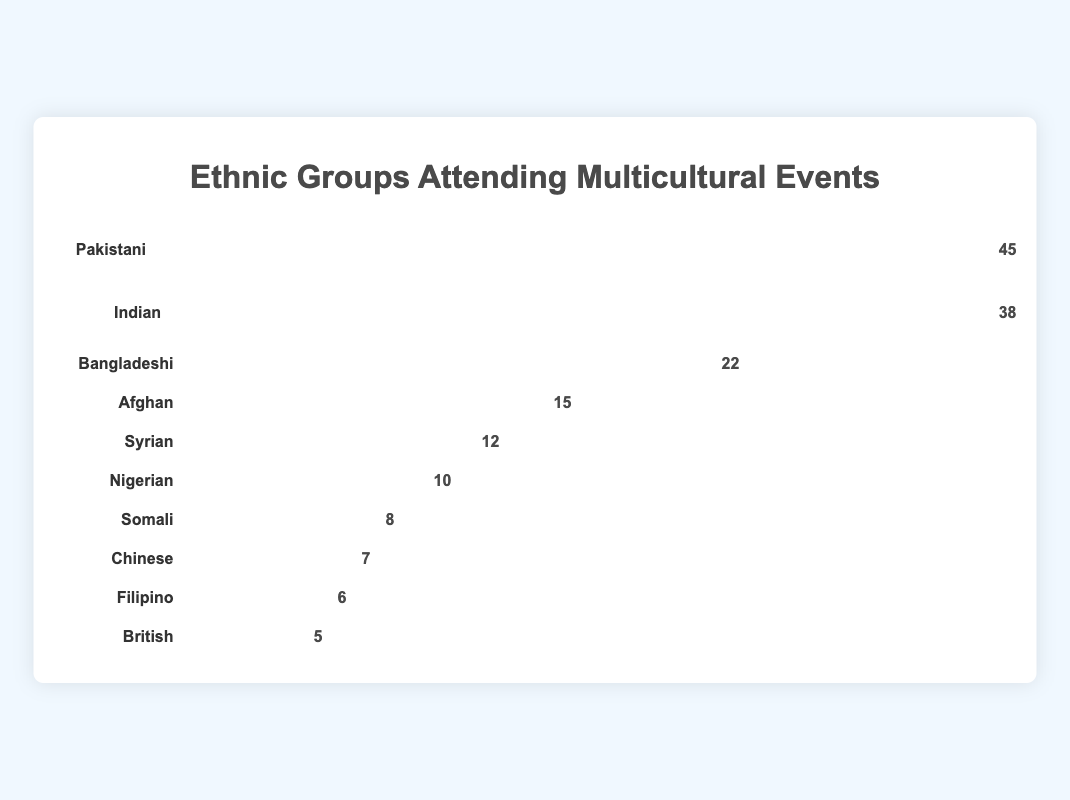How many ethnic groups are represented in the figure? Count the distinct labels for each ethnic group in the figure; there should be a total of 10 unique labels.
Answer: 10 Which ethnic group has the highest attendance? Identify the group with the longest bar and the highest count beside it, which in this case is the Pakistani group with 45 attendees.
Answer: Pakistani How many more attendees are in the Pakistani group compared to the British group? Subtract the count of the British group (5) from the count of the Pakistani group (45): 45 - 5 = 40.
Answer: 40 What is the total number of attendees from all ethnic groups combined? Add up all the counts: 45 + 38 + 22 + 15 + 12 + 10 + 8 + 7 + 6 + 5 = 168.
Answer: 168 Which ethnic group has the smallest attendance, and what is their count? Identify the group with the shortest bar and the lowest count beside it, which is the British group with 5 attendees.
Answer: British, 5 What's the average number of attendees per ethnic group? Calculate the total sum of attendees and divide by the number of groups: 168 / 10 = 16.8.
Answer: 16.8 How does the attendance of the Indian group compare to the Bangladeshi group? The Indian group has 38 attendees, while the Bangladeshi group has 22 attendees. By subtraction: 38 - 22 = 16.
Answer: Indian group has 16 more attendees Which three ethnic groups have the lowest attendance? Identify the three groups with the shortest bars (smallest counts), which are British (5), Filipino (6), and Chinese (7).
Answer: British, Filipino, Chinese What percentage of total attendees does the Nigerian group represent? Divide the Nigerian group's count by the total attendance and multiply by 100: (10 / 168) * 100 ≈ 5.95%.
Answer: Approximately 5.95% How many more attendees does the Pakistani group have compared to the second-highest group (Indian)? Subtract the count of the Indian group from the Pakistani group: 45 - 38 = 7.
Answer: 7 